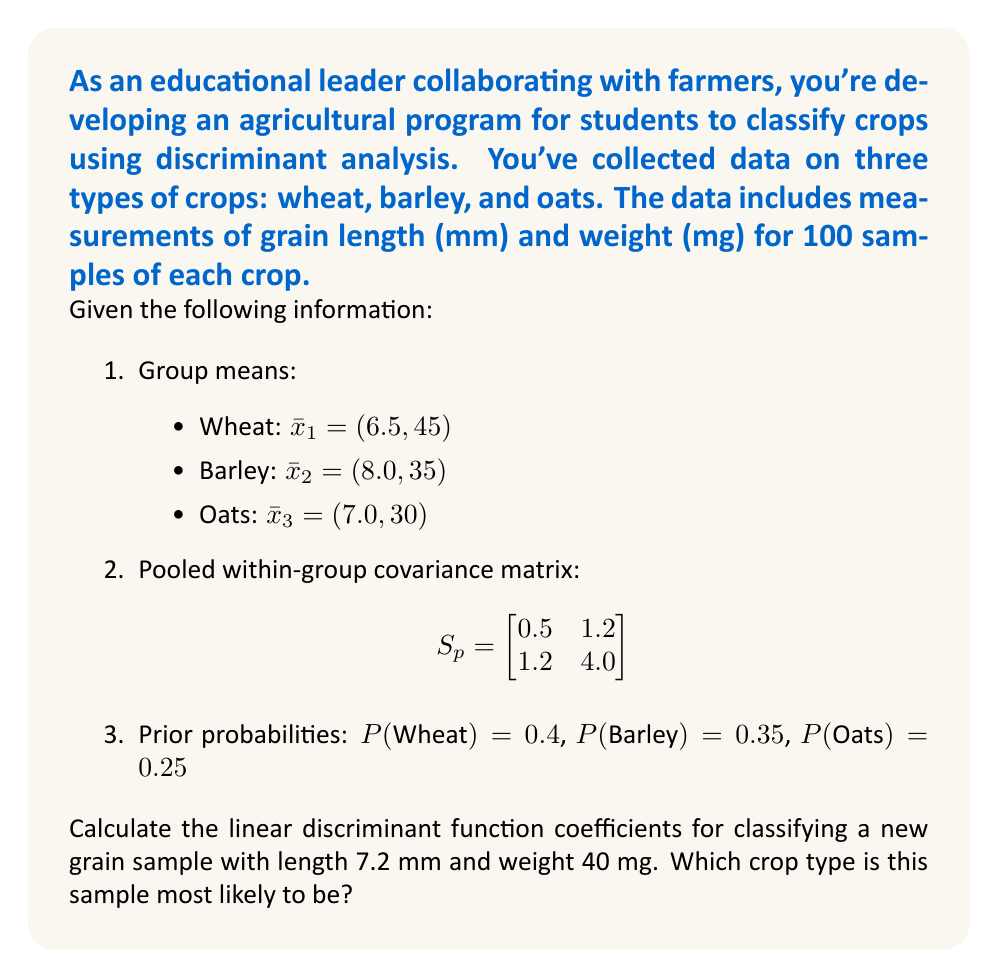Provide a solution to this math problem. To solve this problem, we'll follow these steps:

1) The linear discriminant function for group $i$ is given by:
   $$d_i(x) = \ln(P_i) + \bar{x}_i^T S_p^{-1}x - \frac{1}{2}\bar{x}_i^T S_p^{-1}\bar{x}_i$$

2) First, we need to calculate $S_p^{-1}$:
   $$S_p^{-1} = \frac{1}{0.5 \cdot 4.0 - 1.2 \cdot 1.2} \begin{bmatrix}
   4.0 & -1.2 \\
   -1.2 & 0.5
   \end{bmatrix} = \begin{bmatrix}
   2.5 & -0.75 \\
   -0.75 & 0.3125
   \end{bmatrix}$$

3) Now, let's calculate $\bar{x}_i^T S_p^{-1}$ for each group:
   Wheat: $(6.5, 45) \begin{bmatrix} 2.5 & -0.75 \\ -0.75 & 0.3125 \end{bmatrix} = (0.625, 13.125)$
   Barley: $(8.0, 35) \begin{bmatrix} 2.5 & -0.75 \\ -0.75 & 0.3125 \end{bmatrix} = (13.75, 7.1875)$
   Oats: $(7.0, 30) \begin{bmatrix} 2.5 & -0.75 \\ -0.75 & 0.3125 \end{bmatrix} = (11.25, 5.625)$

4) Calculate $\frac{1}{2}\bar{x}_i^T S_p^{-1}\bar{x}_i$ for each group:
   Wheat: $\frac{1}{2}(0.625 \cdot 6.5 + 13.125 \cdot 45) = 297.65625$
   Barley: $\frac{1}{2}(13.75 \cdot 8.0 + 7.1875 \cdot 35) = 181.09375$
   Oats: $\frac{1}{2}(11.25 \cdot 7.0 + 5.625 \cdot 30) = 123.28125$

5) Now we can form the discriminant functions:
   $d_1(x) = \ln(0.4) + 0.625x_1 + 13.125x_2 - 297.65625$
   $d_2(x) = \ln(0.35) + 13.75x_1 + 7.1875x_2 - 181.09375$
   $d_3(x) = \ln(0.25) + 11.25x_1 + 5.625x_2 - 123.28125$

6) Evaluate these functions for the new sample $(7.2, 40)$:
   $d_1(7.2, 40) = -0.916 + 4.5 + 525 - 297.65625 = 230.92775$
   $d_2(7.2, 40) = -1.0498 + 99 + 287.5 - 181.09375 = 204.35645$
   $d_3(7.2, 40) = -1.3863 + 81 + 225 - 123.28125 = 181.33245$

7) The sample is classified into the group with the highest discriminant function value.
Answer: Wheat (highest discriminant function value: 230.92775) 